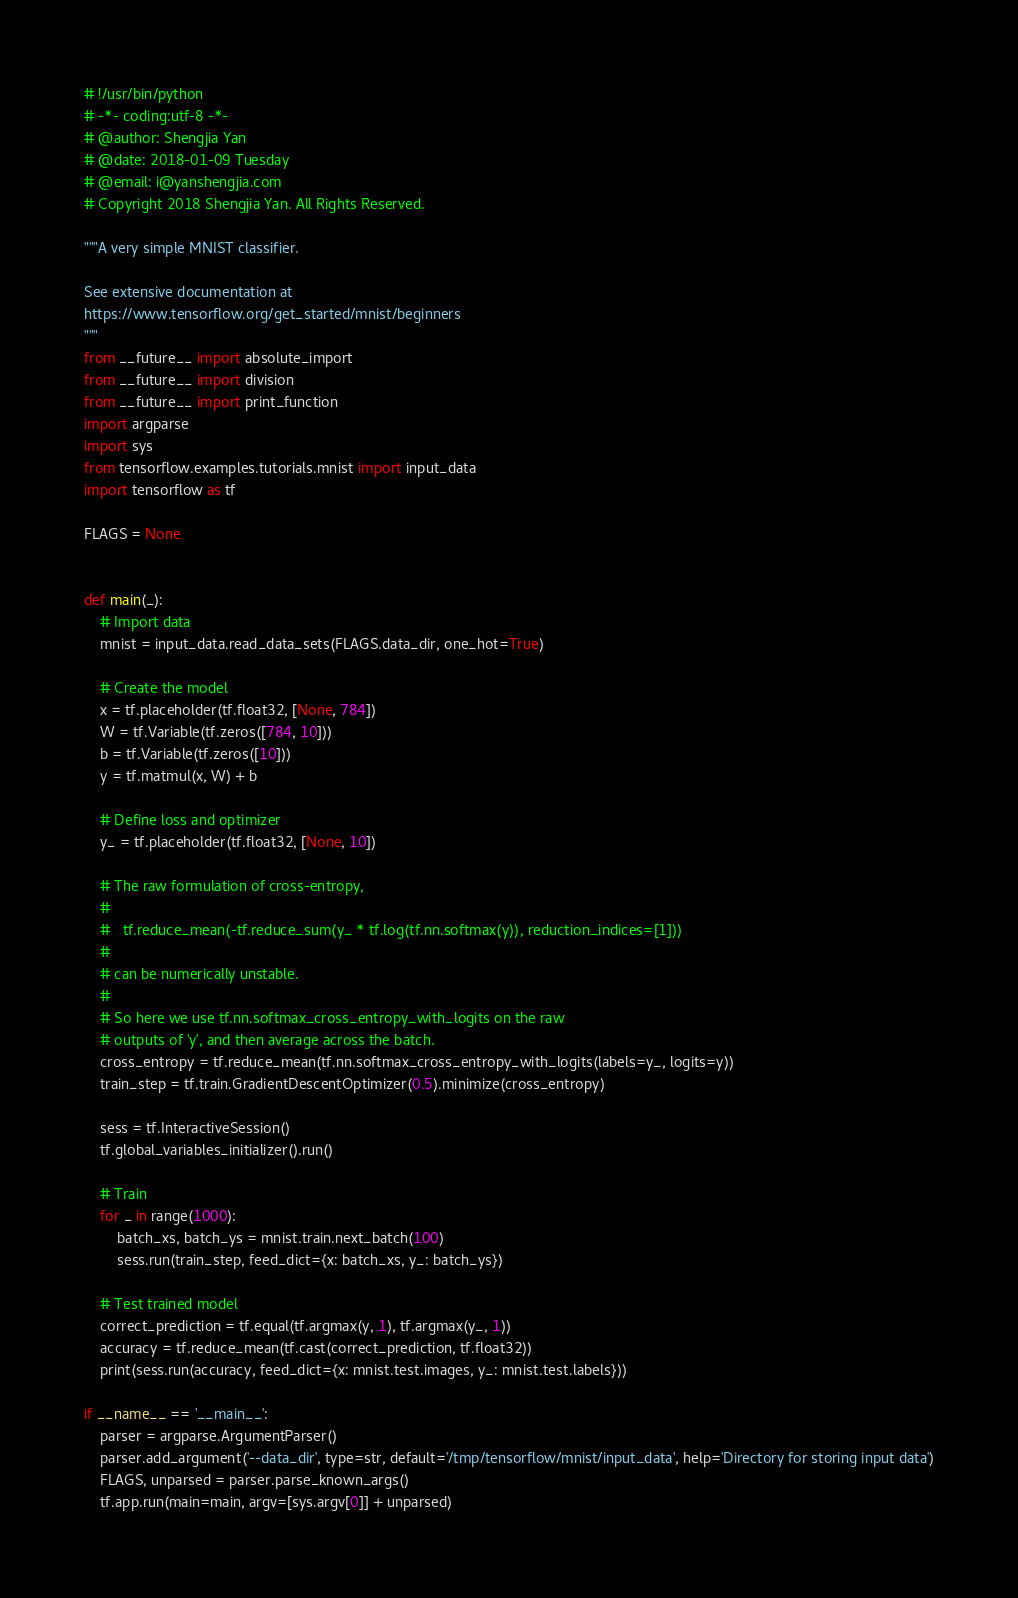Convert code to text. <code><loc_0><loc_0><loc_500><loc_500><_Python_># !/usr/bin/python
# -*- coding:utf-8 -*-  
# @author: Shengjia Yan
# @date: 2018-01-09 Tuesday
# @email: i@yanshengjia.com
# Copyright 2018 Shengjia Yan. All Rights Reserved.

"""A very simple MNIST classifier.

See extensive documentation at
https://www.tensorflow.org/get_started/mnist/beginners
"""
from __future__ import absolute_import
from __future__ import division
from __future__ import print_function
import argparse
import sys
from tensorflow.examples.tutorials.mnist import input_data
import tensorflow as tf

FLAGS = None


def main(_):
    # Import data
    mnist = input_data.read_data_sets(FLAGS.data_dir, one_hot=True)

    # Create the model
    x = tf.placeholder(tf.float32, [None, 784])
    W = tf.Variable(tf.zeros([784, 10]))
    b = tf.Variable(tf.zeros([10]))
    y = tf.matmul(x, W) + b

    # Define loss and optimizer
    y_ = tf.placeholder(tf.float32, [None, 10])

    # The raw formulation of cross-entropy,
    #
    #   tf.reduce_mean(-tf.reduce_sum(y_ * tf.log(tf.nn.softmax(y)), reduction_indices=[1]))
    #
    # can be numerically unstable.
    #
    # So here we use tf.nn.softmax_cross_entropy_with_logits on the raw
    # outputs of 'y', and then average across the batch.
    cross_entropy = tf.reduce_mean(tf.nn.softmax_cross_entropy_with_logits(labels=y_, logits=y))
    train_step = tf.train.GradientDescentOptimizer(0.5).minimize(cross_entropy)

    sess = tf.InteractiveSession()
    tf.global_variables_initializer().run()

    # Train
    for _ in range(1000):
        batch_xs, batch_ys = mnist.train.next_batch(100)
        sess.run(train_step, feed_dict={x: batch_xs, y_: batch_ys})

    # Test trained model
    correct_prediction = tf.equal(tf.argmax(y, 1), tf.argmax(y_, 1))
    accuracy = tf.reduce_mean(tf.cast(correct_prediction, tf.float32))
    print(sess.run(accuracy, feed_dict={x: mnist.test.images, y_: mnist.test.labels}))

if __name__ == '__main__':
    parser = argparse.ArgumentParser()
    parser.add_argument('--data_dir', type=str, default='/tmp/tensorflow/mnist/input_data', help='Directory for storing input data')
    FLAGS, unparsed = parser.parse_known_args()
    tf.app.run(main=main, argv=[sys.argv[0]] + unparsed)</code> 